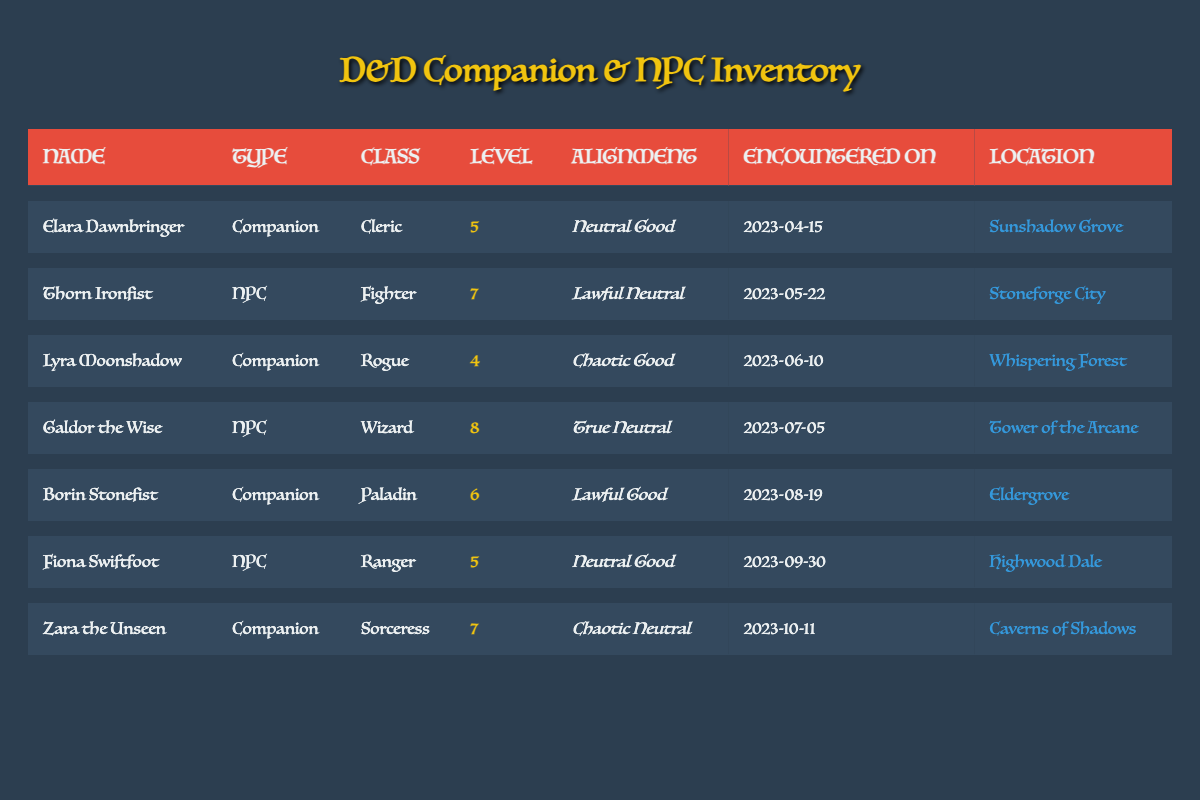What is the alignment of Elara Dawnbringer? Elara Dawnbringer is listed in the inventory table and her alignment is specified in the corresponding column. Looking at her row, it states that her alignment is "Neutral Good".
Answer: Neutral Good How many companions are listed in the table? The table contains specific entries for companions, which can be counted by checking the "type" column for occurrences of the word "Companion". There are 4 such entries: Elara Dawnbringer, Lyra Moonshadow, Borin Stonefist, and Zara the Unseen.
Answer: 4 Who was encountered in the Tower of the Arcane, and what is their class? The location "Tower of the Arcane" appears in the location column. By examining the row corresponding to this location, we find that Galdor the Wise was encountered there, and his class is "Wizard".
Answer: Galdor the Wise, Wizard Is there a companion with a level higher than 6? We need to analyze the levels of all companions listed in the table. The companions and their levels are: Elara (5), Lyra (4), Borin (6), and Zara (7). Since Zara the Unseen has a level of 7, which is greater than 6, the answer is yes.
Answer: Yes What is the average level of NPCs encountered? The NPCs in the table are Thorn Ironfist (level 7), Galdor the Wise (level 8), and Fiona Swiftfoot (level 5). Adding their levels gives 7 + 8 + 5 = 20, and there are 3 NPCs. So, the average level is 20 / 3 = approximately 6.67.
Answer: 6.67 Which character has the highest level among companions? To find this, we look at the levels of all companions: Elara (5), Lyra (4), Borin (6), Zara (7). The highest level among them is Zara the Unseen with a level of 7.
Answer: Zara the Unseen Are there any characters encountered in the Caverns of Shadows? Checking the location column, we see Zara the Unseen is listed as being encountered in the "Caverns of Shadows". Therefore, the answer is yes.
Answer: Yes What is the alignment of Galdor the Wise? Galdor the Wise can be located by searching for his name in the table, where his alignment is recorded. The row indicates his alignment is "True Neutral".
Answer: True Neutral How many NPCs were encountered on or after July 1, 2023? We must check the encounter dates of NPCs: Thorn (May 22), Galdor (July 5), and Fiona (September 30). Only Galdor and Fiona have dates on or after July 1, leading to a total of 2 NPCs.
Answer: 2 